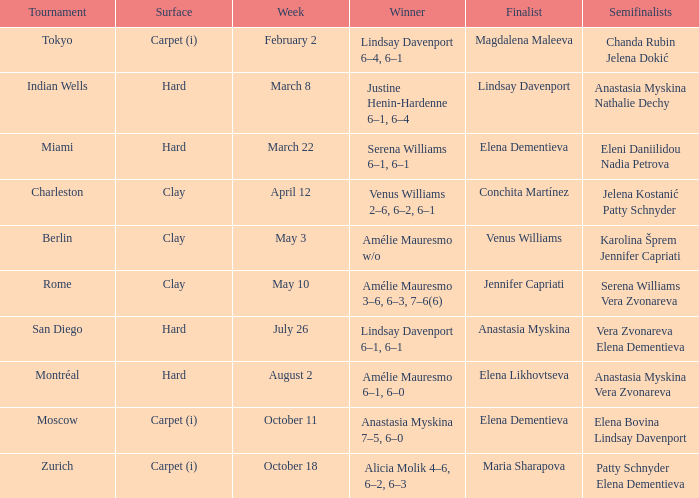Who was the winner of the Miami tournament where Elena Dementieva was a finalist? Serena Williams 6–1, 6–1. 